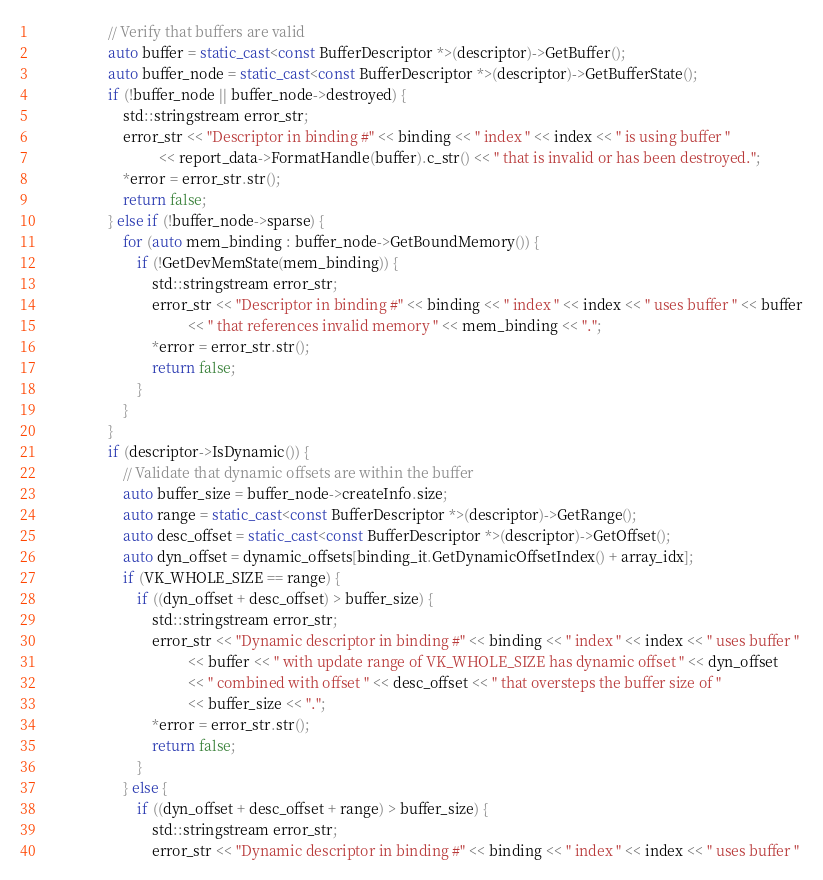Convert code to text. <code><loc_0><loc_0><loc_500><loc_500><_C++_>                    // Verify that buffers are valid
                    auto buffer = static_cast<const BufferDescriptor *>(descriptor)->GetBuffer();
                    auto buffer_node = static_cast<const BufferDescriptor *>(descriptor)->GetBufferState();
                    if (!buffer_node || buffer_node->destroyed) {
                        std::stringstream error_str;
                        error_str << "Descriptor in binding #" << binding << " index " << index << " is using buffer "
                                  << report_data->FormatHandle(buffer).c_str() << " that is invalid or has been destroyed.";
                        *error = error_str.str();
                        return false;
                    } else if (!buffer_node->sparse) {
                        for (auto mem_binding : buffer_node->GetBoundMemory()) {
                            if (!GetDevMemState(mem_binding)) {
                                std::stringstream error_str;
                                error_str << "Descriptor in binding #" << binding << " index " << index << " uses buffer " << buffer
                                          << " that references invalid memory " << mem_binding << ".";
                                *error = error_str.str();
                                return false;
                            }
                        }
                    }
                    if (descriptor->IsDynamic()) {
                        // Validate that dynamic offsets are within the buffer
                        auto buffer_size = buffer_node->createInfo.size;
                        auto range = static_cast<const BufferDescriptor *>(descriptor)->GetRange();
                        auto desc_offset = static_cast<const BufferDescriptor *>(descriptor)->GetOffset();
                        auto dyn_offset = dynamic_offsets[binding_it.GetDynamicOffsetIndex() + array_idx];
                        if (VK_WHOLE_SIZE == range) {
                            if ((dyn_offset + desc_offset) > buffer_size) {
                                std::stringstream error_str;
                                error_str << "Dynamic descriptor in binding #" << binding << " index " << index << " uses buffer "
                                          << buffer << " with update range of VK_WHOLE_SIZE has dynamic offset " << dyn_offset
                                          << " combined with offset " << desc_offset << " that oversteps the buffer size of "
                                          << buffer_size << ".";
                                *error = error_str.str();
                                return false;
                            }
                        } else {
                            if ((dyn_offset + desc_offset + range) > buffer_size) {
                                std::stringstream error_str;
                                error_str << "Dynamic descriptor in binding #" << binding << " index " << index << " uses buffer "</code> 